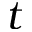Convert formula to latex. <formula><loc_0><loc_0><loc_500><loc_500>t</formula> 